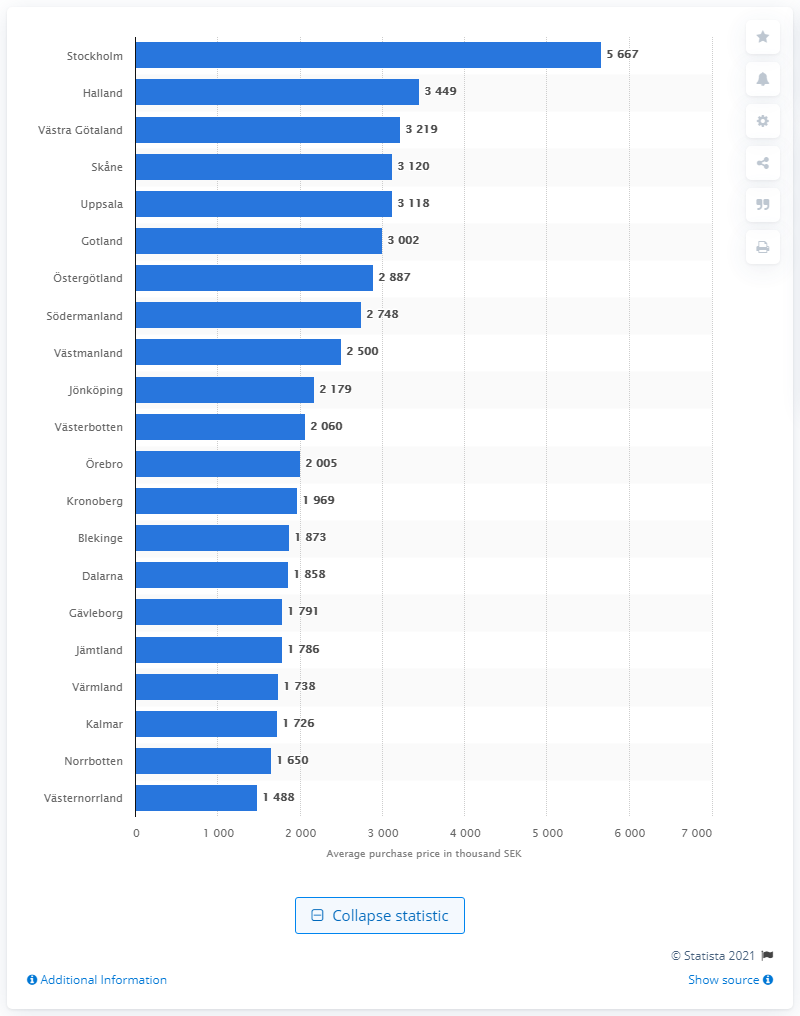What regions have median purchase prices close to 3000 thousand SEK? The regions with median purchase prices close to 3000 thousand SEK are Halland, Västra Götaland, and Skåne. 